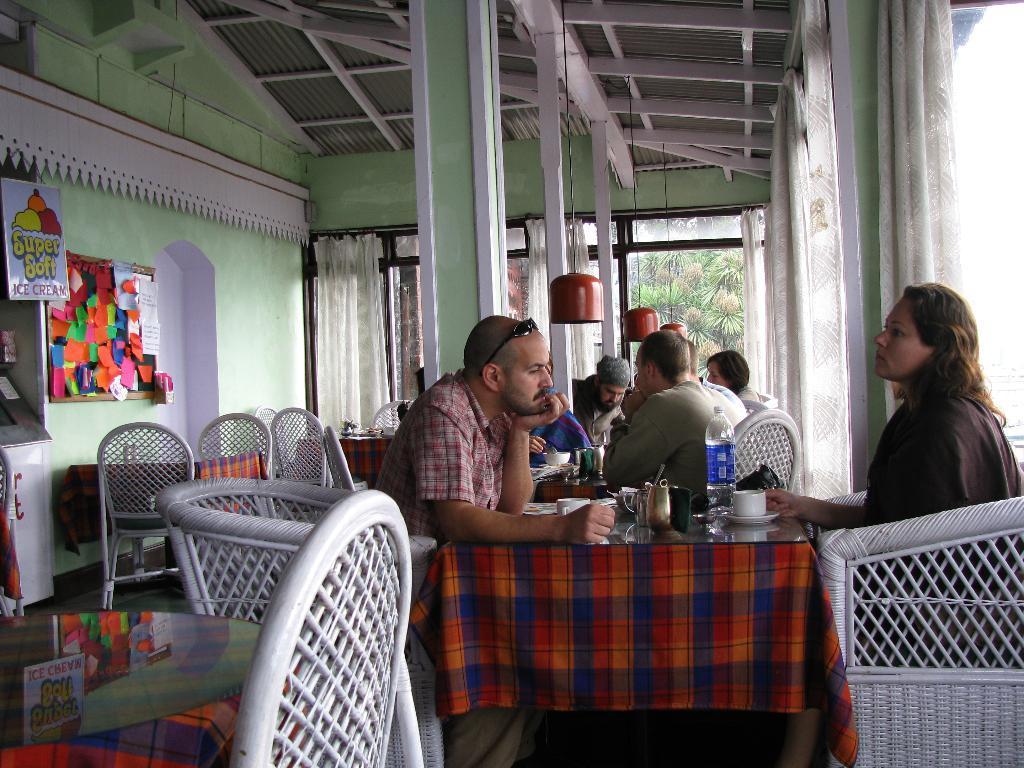Could you give a brief overview of what you see in this image? There are few people sat in a restaurant and there is a table in front of them and the table consist of a cup and water bottle and the walls are green in color. 